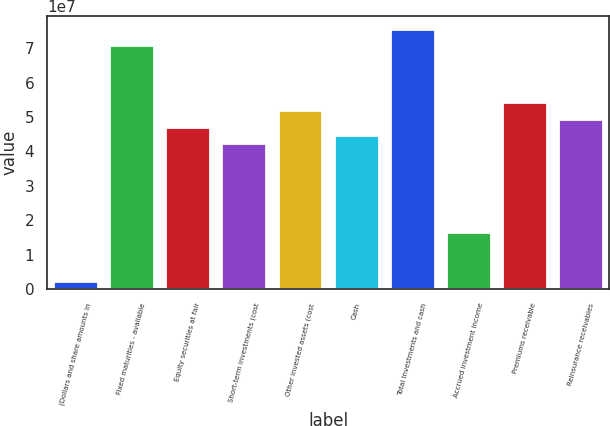Convert chart to OTSL. <chart><loc_0><loc_0><loc_500><loc_500><bar_chart><fcel>(Dollars and share amounts in<fcel>Fixed maturities - available<fcel>Equity securities at fair<fcel>Short-term investments (cost<fcel>Other invested assets (cost<fcel>Cash<fcel>Total investments and cash<fcel>Accrued investment income<fcel>Premiums receivable<fcel>Reinsurance receivables<nl><fcel>2.3598e+06<fcel>7.0774e+07<fcel>4.71829e+07<fcel>4.24647e+07<fcel>5.19011e+07<fcel>4.48238e+07<fcel>7.54922e+07<fcel>1.65145e+07<fcel>5.42602e+07<fcel>4.9542e+07<nl></chart> 